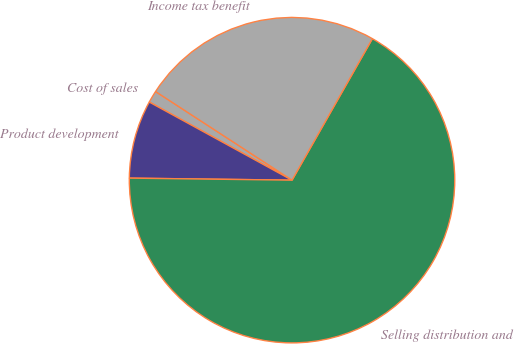Convert chart. <chart><loc_0><loc_0><loc_500><loc_500><pie_chart><fcel>Cost of sales<fcel>Product development<fcel>Selling distribution and<fcel>Income tax benefit<nl><fcel>1.2%<fcel>7.77%<fcel>66.98%<fcel>24.05%<nl></chart> 